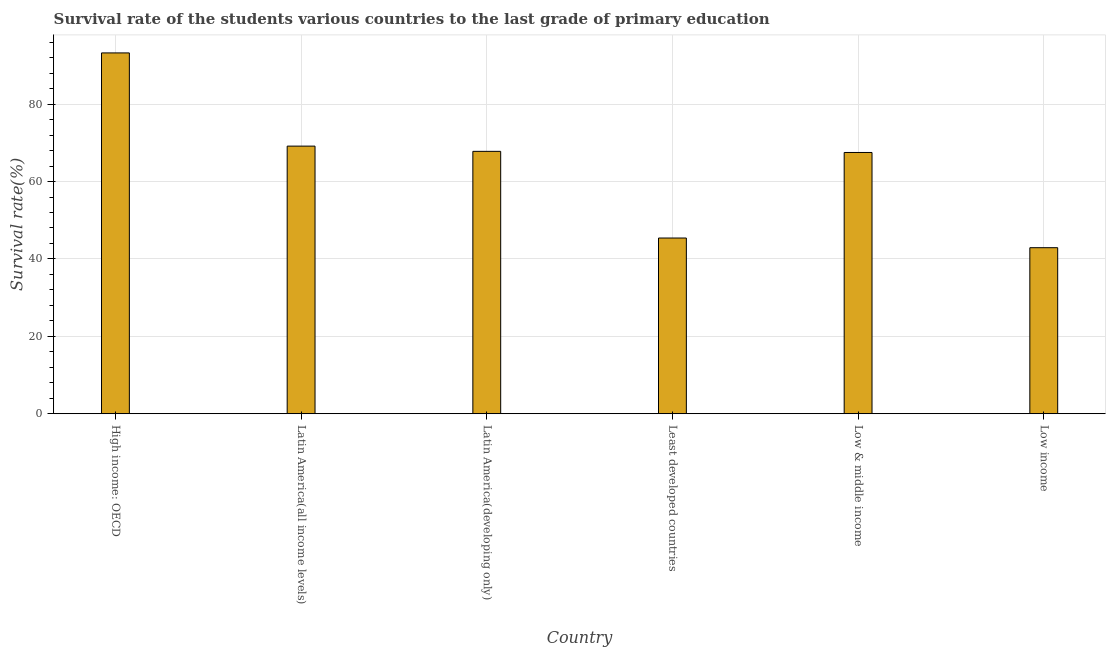Does the graph contain any zero values?
Make the answer very short. No. What is the title of the graph?
Provide a short and direct response. Survival rate of the students various countries to the last grade of primary education. What is the label or title of the Y-axis?
Keep it short and to the point. Survival rate(%). What is the survival rate in primary education in High income: OECD?
Your answer should be very brief. 93.23. Across all countries, what is the maximum survival rate in primary education?
Your answer should be very brief. 93.23. Across all countries, what is the minimum survival rate in primary education?
Give a very brief answer. 42.9. In which country was the survival rate in primary education maximum?
Your answer should be compact. High income: OECD. In which country was the survival rate in primary education minimum?
Your answer should be compact. Low income. What is the sum of the survival rate in primary education?
Offer a very short reply. 385.99. What is the difference between the survival rate in primary education in Latin America(all income levels) and Least developed countries?
Keep it short and to the point. 23.75. What is the average survival rate in primary education per country?
Give a very brief answer. 64.33. What is the median survival rate in primary education?
Provide a short and direct response. 67.65. In how many countries, is the survival rate in primary education greater than 80 %?
Make the answer very short. 1. What is the ratio of the survival rate in primary education in Latin America(all income levels) to that in Low income?
Your response must be concise. 1.61. Is the survival rate in primary education in Low & middle income less than that in Low income?
Provide a short and direct response. No. Is the difference between the survival rate in primary education in High income: OECD and Low income greater than the difference between any two countries?
Your answer should be very brief. Yes. What is the difference between the highest and the second highest survival rate in primary education?
Provide a succinct answer. 24.08. Is the sum of the survival rate in primary education in Latin America(developing only) and Low income greater than the maximum survival rate in primary education across all countries?
Provide a succinct answer. Yes. What is the difference between the highest and the lowest survival rate in primary education?
Your answer should be compact. 50.33. How many bars are there?
Make the answer very short. 6. Are the values on the major ticks of Y-axis written in scientific E-notation?
Your answer should be compact. No. What is the Survival rate(%) of High income: OECD?
Your answer should be very brief. 93.23. What is the Survival rate(%) of Latin America(all income levels)?
Ensure brevity in your answer.  69.15. What is the Survival rate(%) in Latin America(developing only)?
Your answer should be compact. 67.8. What is the Survival rate(%) of Least developed countries?
Your response must be concise. 45.4. What is the Survival rate(%) in Low & middle income?
Ensure brevity in your answer.  67.51. What is the Survival rate(%) of Low income?
Give a very brief answer. 42.9. What is the difference between the Survival rate(%) in High income: OECD and Latin America(all income levels)?
Your answer should be very brief. 24.08. What is the difference between the Survival rate(%) in High income: OECD and Latin America(developing only)?
Provide a succinct answer. 25.44. What is the difference between the Survival rate(%) in High income: OECD and Least developed countries?
Offer a very short reply. 47.83. What is the difference between the Survival rate(%) in High income: OECD and Low & middle income?
Offer a terse response. 25.73. What is the difference between the Survival rate(%) in High income: OECD and Low income?
Give a very brief answer. 50.33. What is the difference between the Survival rate(%) in Latin America(all income levels) and Latin America(developing only)?
Offer a terse response. 1.35. What is the difference between the Survival rate(%) in Latin America(all income levels) and Least developed countries?
Offer a terse response. 23.75. What is the difference between the Survival rate(%) in Latin America(all income levels) and Low & middle income?
Ensure brevity in your answer.  1.64. What is the difference between the Survival rate(%) in Latin America(all income levels) and Low income?
Offer a very short reply. 26.25. What is the difference between the Survival rate(%) in Latin America(developing only) and Least developed countries?
Offer a terse response. 22.4. What is the difference between the Survival rate(%) in Latin America(developing only) and Low & middle income?
Ensure brevity in your answer.  0.29. What is the difference between the Survival rate(%) in Latin America(developing only) and Low income?
Give a very brief answer. 24.89. What is the difference between the Survival rate(%) in Least developed countries and Low & middle income?
Make the answer very short. -22.11. What is the difference between the Survival rate(%) in Least developed countries and Low income?
Give a very brief answer. 2.5. What is the difference between the Survival rate(%) in Low & middle income and Low income?
Provide a succinct answer. 24.61. What is the ratio of the Survival rate(%) in High income: OECD to that in Latin America(all income levels)?
Provide a short and direct response. 1.35. What is the ratio of the Survival rate(%) in High income: OECD to that in Latin America(developing only)?
Provide a short and direct response. 1.38. What is the ratio of the Survival rate(%) in High income: OECD to that in Least developed countries?
Offer a terse response. 2.05. What is the ratio of the Survival rate(%) in High income: OECD to that in Low & middle income?
Keep it short and to the point. 1.38. What is the ratio of the Survival rate(%) in High income: OECD to that in Low income?
Your response must be concise. 2.17. What is the ratio of the Survival rate(%) in Latin America(all income levels) to that in Least developed countries?
Provide a succinct answer. 1.52. What is the ratio of the Survival rate(%) in Latin America(all income levels) to that in Low & middle income?
Your answer should be compact. 1.02. What is the ratio of the Survival rate(%) in Latin America(all income levels) to that in Low income?
Give a very brief answer. 1.61. What is the ratio of the Survival rate(%) in Latin America(developing only) to that in Least developed countries?
Make the answer very short. 1.49. What is the ratio of the Survival rate(%) in Latin America(developing only) to that in Low income?
Offer a very short reply. 1.58. What is the ratio of the Survival rate(%) in Least developed countries to that in Low & middle income?
Give a very brief answer. 0.67. What is the ratio of the Survival rate(%) in Least developed countries to that in Low income?
Your response must be concise. 1.06. What is the ratio of the Survival rate(%) in Low & middle income to that in Low income?
Provide a short and direct response. 1.57. 